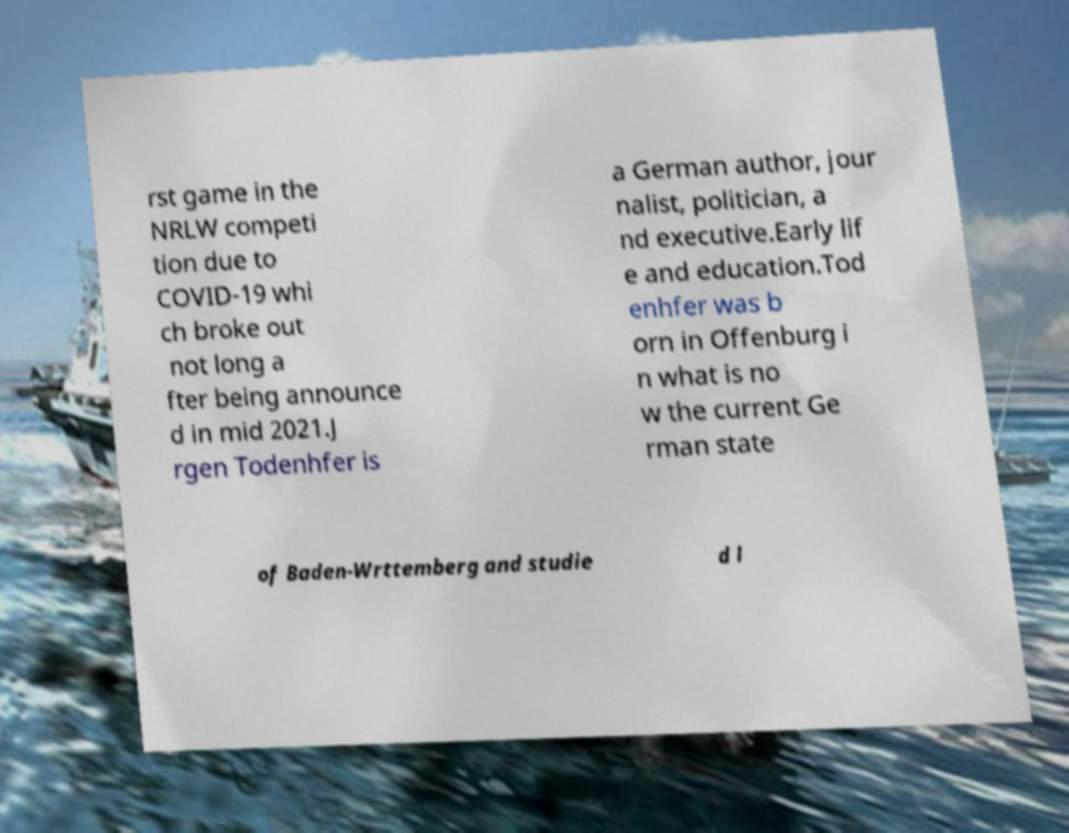For documentation purposes, I need the text within this image transcribed. Could you provide that? rst game in the NRLW competi tion due to COVID-19 whi ch broke out not long a fter being announce d in mid 2021.J rgen Todenhfer is a German author, jour nalist, politician, a nd executive.Early lif e and education.Tod enhfer was b orn in Offenburg i n what is no w the current Ge rman state of Baden-Wrttemberg and studie d l 